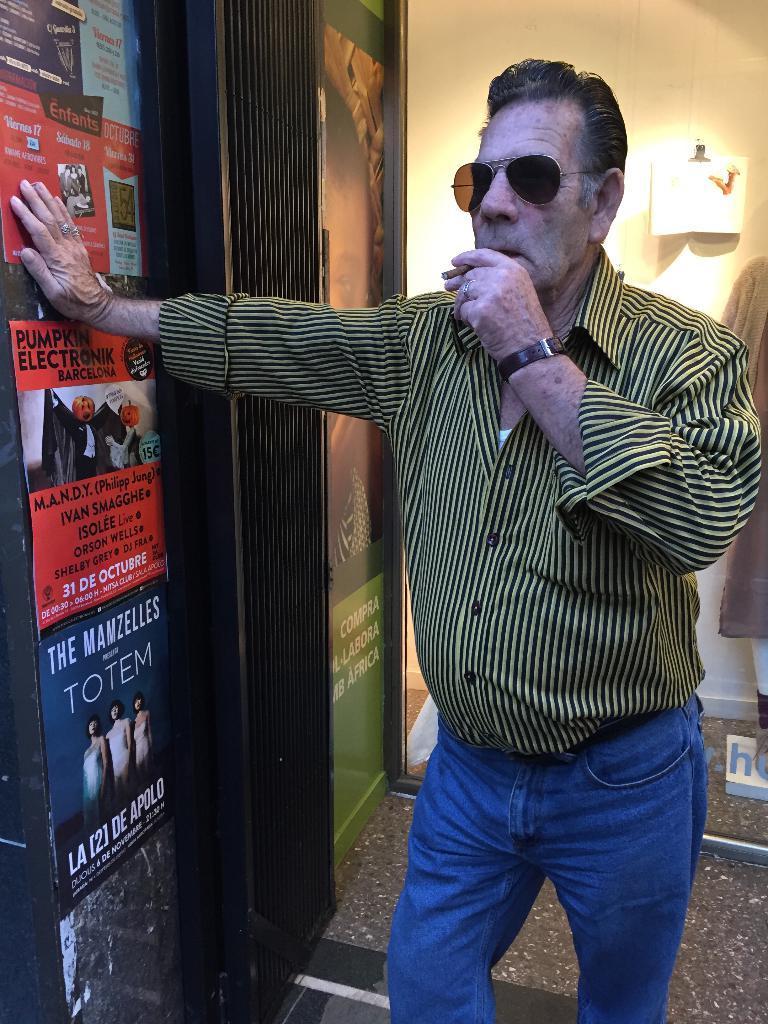Please provide a concise description of this image. In this image we can see a man is standing and holding a cigarette in his hand and placed his other hand on a poster which is on the wall and there are posters on the wall. In the background we can see a glass, clothes to a mannequin, light and other objects. 